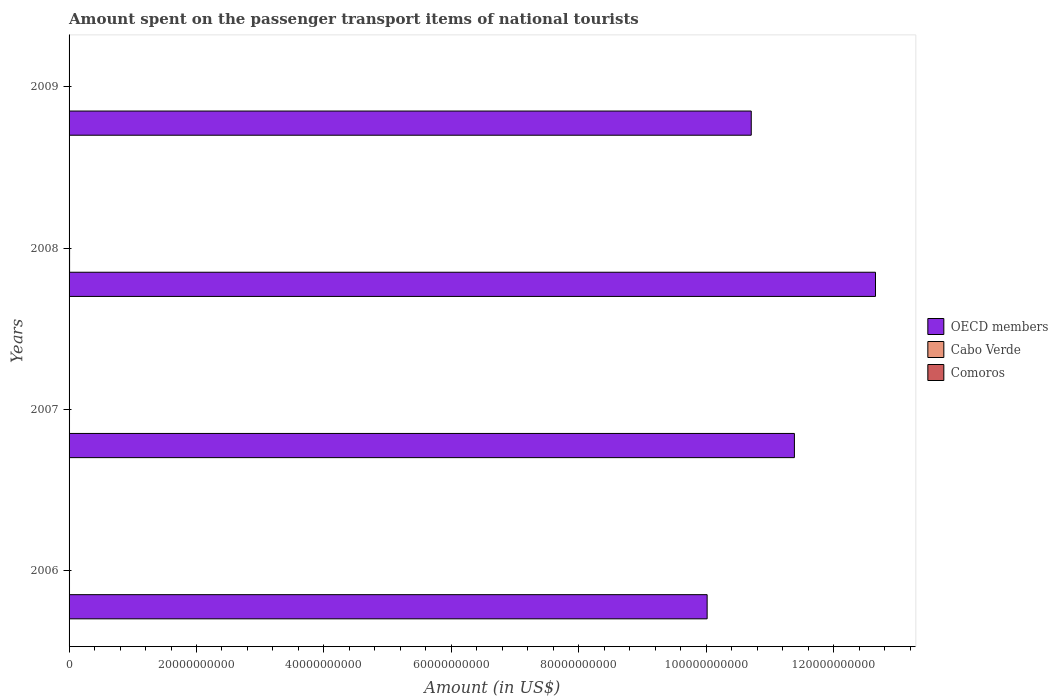How many different coloured bars are there?
Ensure brevity in your answer.  3. How many groups of bars are there?
Keep it short and to the point. 4. Are the number of bars per tick equal to the number of legend labels?
Make the answer very short. Yes. Are the number of bars on each tick of the Y-axis equal?
Make the answer very short. Yes. How many bars are there on the 1st tick from the bottom?
Keep it short and to the point. 3. What is the label of the 1st group of bars from the top?
Provide a succinct answer. 2009. In how many cases, is the number of bars for a given year not equal to the number of legend labels?
Offer a terse response. 0. What is the amount spent on the passenger transport items of national tourists in Comoros in 2008?
Make the answer very short. 4.00e+05. Across all years, what is the maximum amount spent on the passenger transport items of national tourists in Comoros?
Make the answer very short. 4.00e+05. Across all years, what is the minimum amount spent on the passenger transport items of national tourists in OECD members?
Ensure brevity in your answer.  1.00e+11. In which year was the amount spent on the passenger transport items of national tourists in OECD members maximum?
Your answer should be very brief. 2008. What is the total amount spent on the passenger transport items of national tourists in Cabo Verde in the graph?
Make the answer very short. 2.85e+08. What is the difference between the amount spent on the passenger transport items of national tourists in Comoros in 2006 and that in 2008?
Provide a succinct answer. 0. What is the difference between the amount spent on the passenger transport items of national tourists in Cabo Verde in 2006 and the amount spent on the passenger transport items of national tourists in Comoros in 2007?
Offer a terse response. 7.06e+07. What is the average amount spent on the passenger transport items of national tourists in Comoros per year?
Your response must be concise. 3.62e+05. In the year 2006, what is the difference between the amount spent on the passenger transport items of national tourists in Cabo Verde and amount spent on the passenger transport items of national tourists in Comoros?
Make the answer very short. 7.06e+07. In how many years, is the amount spent on the passenger transport items of national tourists in Comoros greater than 52000000000 US$?
Provide a succinct answer. 0. What is the ratio of the amount spent on the passenger transport items of national tourists in OECD members in 2007 to that in 2009?
Offer a terse response. 1.06. Is the amount spent on the passenger transport items of national tourists in Cabo Verde in 2006 less than that in 2008?
Offer a terse response. Yes. Is the difference between the amount spent on the passenger transport items of national tourists in Cabo Verde in 2006 and 2007 greater than the difference between the amount spent on the passenger transport items of national tourists in Comoros in 2006 and 2007?
Offer a very short reply. No. What is the difference between the highest and the second highest amount spent on the passenger transport items of national tourists in Cabo Verde?
Ensure brevity in your answer.  9.00e+06. What is the difference between the highest and the lowest amount spent on the passenger transport items of national tourists in Comoros?
Offer a very short reply. 1.50e+05. Is the sum of the amount spent on the passenger transport items of national tourists in Cabo Verde in 2007 and 2009 greater than the maximum amount spent on the passenger transport items of national tourists in OECD members across all years?
Ensure brevity in your answer.  No. What does the 2nd bar from the top in 2009 represents?
Your response must be concise. Cabo Verde. What does the 2nd bar from the bottom in 2006 represents?
Give a very brief answer. Cabo Verde. Is it the case that in every year, the sum of the amount spent on the passenger transport items of national tourists in Comoros and amount spent on the passenger transport items of national tourists in Cabo Verde is greater than the amount spent on the passenger transport items of national tourists in OECD members?
Offer a terse response. No. Are all the bars in the graph horizontal?
Provide a short and direct response. Yes. Does the graph contain any zero values?
Ensure brevity in your answer.  No. Where does the legend appear in the graph?
Give a very brief answer. Center right. How are the legend labels stacked?
Offer a very short reply. Vertical. What is the title of the graph?
Offer a very short reply. Amount spent on the passenger transport items of national tourists. What is the label or title of the Y-axis?
Your response must be concise. Years. What is the Amount (in US$) in OECD members in 2006?
Ensure brevity in your answer.  1.00e+11. What is the Amount (in US$) of Cabo Verde in 2006?
Offer a terse response. 7.10e+07. What is the Amount (in US$) in OECD members in 2007?
Provide a succinct answer. 1.14e+11. What is the Amount (in US$) in Cabo Verde in 2007?
Make the answer very short. 7.10e+07. What is the Amount (in US$) in OECD members in 2008?
Make the answer very short. 1.27e+11. What is the Amount (in US$) of Cabo Verde in 2008?
Provide a succinct answer. 8.00e+07. What is the Amount (in US$) in OECD members in 2009?
Your answer should be compact. 1.07e+11. What is the Amount (in US$) in Cabo Verde in 2009?
Your answer should be very brief. 6.30e+07. Across all years, what is the maximum Amount (in US$) in OECD members?
Your response must be concise. 1.27e+11. Across all years, what is the maximum Amount (in US$) in Cabo Verde?
Make the answer very short. 8.00e+07. Across all years, what is the minimum Amount (in US$) in OECD members?
Provide a short and direct response. 1.00e+11. Across all years, what is the minimum Amount (in US$) in Cabo Verde?
Your response must be concise. 6.30e+07. What is the total Amount (in US$) in OECD members in the graph?
Provide a short and direct response. 4.48e+11. What is the total Amount (in US$) in Cabo Verde in the graph?
Offer a terse response. 2.85e+08. What is the total Amount (in US$) of Comoros in the graph?
Make the answer very short. 1.45e+06. What is the difference between the Amount (in US$) in OECD members in 2006 and that in 2007?
Provide a short and direct response. -1.37e+1. What is the difference between the Amount (in US$) of Cabo Verde in 2006 and that in 2007?
Offer a very short reply. 0. What is the difference between the Amount (in US$) of Comoros in 2006 and that in 2007?
Keep it short and to the point. 0. What is the difference between the Amount (in US$) of OECD members in 2006 and that in 2008?
Make the answer very short. -2.64e+1. What is the difference between the Amount (in US$) of Cabo Verde in 2006 and that in 2008?
Ensure brevity in your answer.  -9.00e+06. What is the difference between the Amount (in US$) in Comoros in 2006 and that in 2008?
Offer a terse response. 0. What is the difference between the Amount (in US$) in OECD members in 2006 and that in 2009?
Ensure brevity in your answer.  -6.92e+09. What is the difference between the Amount (in US$) in OECD members in 2007 and that in 2008?
Your answer should be compact. -1.27e+1. What is the difference between the Amount (in US$) in Cabo Verde in 2007 and that in 2008?
Provide a succinct answer. -9.00e+06. What is the difference between the Amount (in US$) of OECD members in 2007 and that in 2009?
Provide a succinct answer. 6.77e+09. What is the difference between the Amount (in US$) of OECD members in 2008 and that in 2009?
Provide a succinct answer. 1.95e+1. What is the difference between the Amount (in US$) in Cabo Verde in 2008 and that in 2009?
Your response must be concise. 1.70e+07. What is the difference between the Amount (in US$) of Comoros in 2008 and that in 2009?
Your answer should be very brief. 1.50e+05. What is the difference between the Amount (in US$) in OECD members in 2006 and the Amount (in US$) in Cabo Verde in 2007?
Make the answer very short. 1.00e+11. What is the difference between the Amount (in US$) of OECD members in 2006 and the Amount (in US$) of Comoros in 2007?
Make the answer very short. 1.00e+11. What is the difference between the Amount (in US$) in Cabo Verde in 2006 and the Amount (in US$) in Comoros in 2007?
Your response must be concise. 7.06e+07. What is the difference between the Amount (in US$) of OECD members in 2006 and the Amount (in US$) of Cabo Verde in 2008?
Ensure brevity in your answer.  1.00e+11. What is the difference between the Amount (in US$) of OECD members in 2006 and the Amount (in US$) of Comoros in 2008?
Your response must be concise. 1.00e+11. What is the difference between the Amount (in US$) of Cabo Verde in 2006 and the Amount (in US$) of Comoros in 2008?
Provide a succinct answer. 7.06e+07. What is the difference between the Amount (in US$) of OECD members in 2006 and the Amount (in US$) of Cabo Verde in 2009?
Your response must be concise. 1.00e+11. What is the difference between the Amount (in US$) of OECD members in 2006 and the Amount (in US$) of Comoros in 2009?
Offer a very short reply. 1.00e+11. What is the difference between the Amount (in US$) in Cabo Verde in 2006 and the Amount (in US$) in Comoros in 2009?
Make the answer very short. 7.08e+07. What is the difference between the Amount (in US$) of OECD members in 2007 and the Amount (in US$) of Cabo Verde in 2008?
Provide a short and direct response. 1.14e+11. What is the difference between the Amount (in US$) in OECD members in 2007 and the Amount (in US$) in Comoros in 2008?
Provide a short and direct response. 1.14e+11. What is the difference between the Amount (in US$) of Cabo Verde in 2007 and the Amount (in US$) of Comoros in 2008?
Provide a succinct answer. 7.06e+07. What is the difference between the Amount (in US$) in OECD members in 2007 and the Amount (in US$) in Cabo Verde in 2009?
Offer a terse response. 1.14e+11. What is the difference between the Amount (in US$) in OECD members in 2007 and the Amount (in US$) in Comoros in 2009?
Your response must be concise. 1.14e+11. What is the difference between the Amount (in US$) in Cabo Verde in 2007 and the Amount (in US$) in Comoros in 2009?
Offer a terse response. 7.08e+07. What is the difference between the Amount (in US$) in OECD members in 2008 and the Amount (in US$) in Cabo Verde in 2009?
Ensure brevity in your answer.  1.27e+11. What is the difference between the Amount (in US$) in OECD members in 2008 and the Amount (in US$) in Comoros in 2009?
Offer a terse response. 1.27e+11. What is the difference between the Amount (in US$) of Cabo Verde in 2008 and the Amount (in US$) of Comoros in 2009?
Provide a short and direct response. 7.98e+07. What is the average Amount (in US$) of OECD members per year?
Keep it short and to the point. 1.12e+11. What is the average Amount (in US$) in Cabo Verde per year?
Offer a very short reply. 7.12e+07. What is the average Amount (in US$) of Comoros per year?
Your answer should be very brief. 3.62e+05. In the year 2006, what is the difference between the Amount (in US$) in OECD members and Amount (in US$) in Cabo Verde?
Provide a short and direct response. 1.00e+11. In the year 2006, what is the difference between the Amount (in US$) in OECD members and Amount (in US$) in Comoros?
Provide a short and direct response. 1.00e+11. In the year 2006, what is the difference between the Amount (in US$) in Cabo Verde and Amount (in US$) in Comoros?
Keep it short and to the point. 7.06e+07. In the year 2007, what is the difference between the Amount (in US$) in OECD members and Amount (in US$) in Cabo Verde?
Provide a succinct answer. 1.14e+11. In the year 2007, what is the difference between the Amount (in US$) of OECD members and Amount (in US$) of Comoros?
Your response must be concise. 1.14e+11. In the year 2007, what is the difference between the Amount (in US$) of Cabo Verde and Amount (in US$) of Comoros?
Offer a very short reply. 7.06e+07. In the year 2008, what is the difference between the Amount (in US$) of OECD members and Amount (in US$) of Cabo Verde?
Provide a short and direct response. 1.26e+11. In the year 2008, what is the difference between the Amount (in US$) in OECD members and Amount (in US$) in Comoros?
Offer a very short reply. 1.27e+11. In the year 2008, what is the difference between the Amount (in US$) of Cabo Verde and Amount (in US$) of Comoros?
Your answer should be very brief. 7.96e+07. In the year 2009, what is the difference between the Amount (in US$) of OECD members and Amount (in US$) of Cabo Verde?
Provide a succinct answer. 1.07e+11. In the year 2009, what is the difference between the Amount (in US$) of OECD members and Amount (in US$) of Comoros?
Your response must be concise. 1.07e+11. In the year 2009, what is the difference between the Amount (in US$) in Cabo Verde and Amount (in US$) in Comoros?
Make the answer very short. 6.28e+07. What is the ratio of the Amount (in US$) of OECD members in 2006 to that in 2007?
Provide a short and direct response. 0.88. What is the ratio of the Amount (in US$) in Cabo Verde in 2006 to that in 2007?
Ensure brevity in your answer.  1. What is the ratio of the Amount (in US$) of OECD members in 2006 to that in 2008?
Give a very brief answer. 0.79. What is the ratio of the Amount (in US$) of Cabo Verde in 2006 to that in 2008?
Keep it short and to the point. 0.89. What is the ratio of the Amount (in US$) of OECD members in 2006 to that in 2009?
Offer a terse response. 0.94. What is the ratio of the Amount (in US$) of Cabo Verde in 2006 to that in 2009?
Offer a terse response. 1.13. What is the ratio of the Amount (in US$) of OECD members in 2007 to that in 2008?
Your answer should be compact. 0.9. What is the ratio of the Amount (in US$) in Cabo Verde in 2007 to that in 2008?
Provide a succinct answer. 0.89. What is the ratio of the Amount (in US$) in Comoros in 2007 to that in 2008?
Your response must be concise. 1. What is the ratio of the Amount (in US$) of OECD members in 2007 to that in 2009?
Provide a short and direct response. 1.06. What is the ratio of the Amount (in US$) of Cabo Verde in 2007 to that in 2009?
Provide a succinct answer. 1.13. What is the ratio of the Amount (in US$) of Comoros in 2007 to that in 2009?
Offer a very short reply. 1.6. What is the ratio of the Amount (in US$) in OECD members in 2008 to that in 2009?
Your answer should be compact. 1.18. What is the ratio of the Amount (in US$) of Cabo Verde in 2008 to that in 2009?
Ensure brevity in your answer.  1.27. What is the difference between the highest and the second highest Amount (in US$) of OECD members?
Your response must be concise. 1.27e+1. What is the difference between the highest and the second highest Amount (in US$) in Cabo Verde?
Give a very brief answer. 9.00e+06. What is the difference between the highest and the second highest Amount (in US$) of Comoros?
Offer a terse response. 0. What is the difference between the highest and the lowest Amount (in US$) of OECD members?
Keep it short and to the point. 2.64e+1. What is the difference between the highest and the lowest Amount (in US$) in Cabo Verde?
Your response must be concise. 1.70e+07. What is the difference between the highest and the lowest Amount (in US$) in Comoros?
Provide a succinct answer. 1.50e+05. 